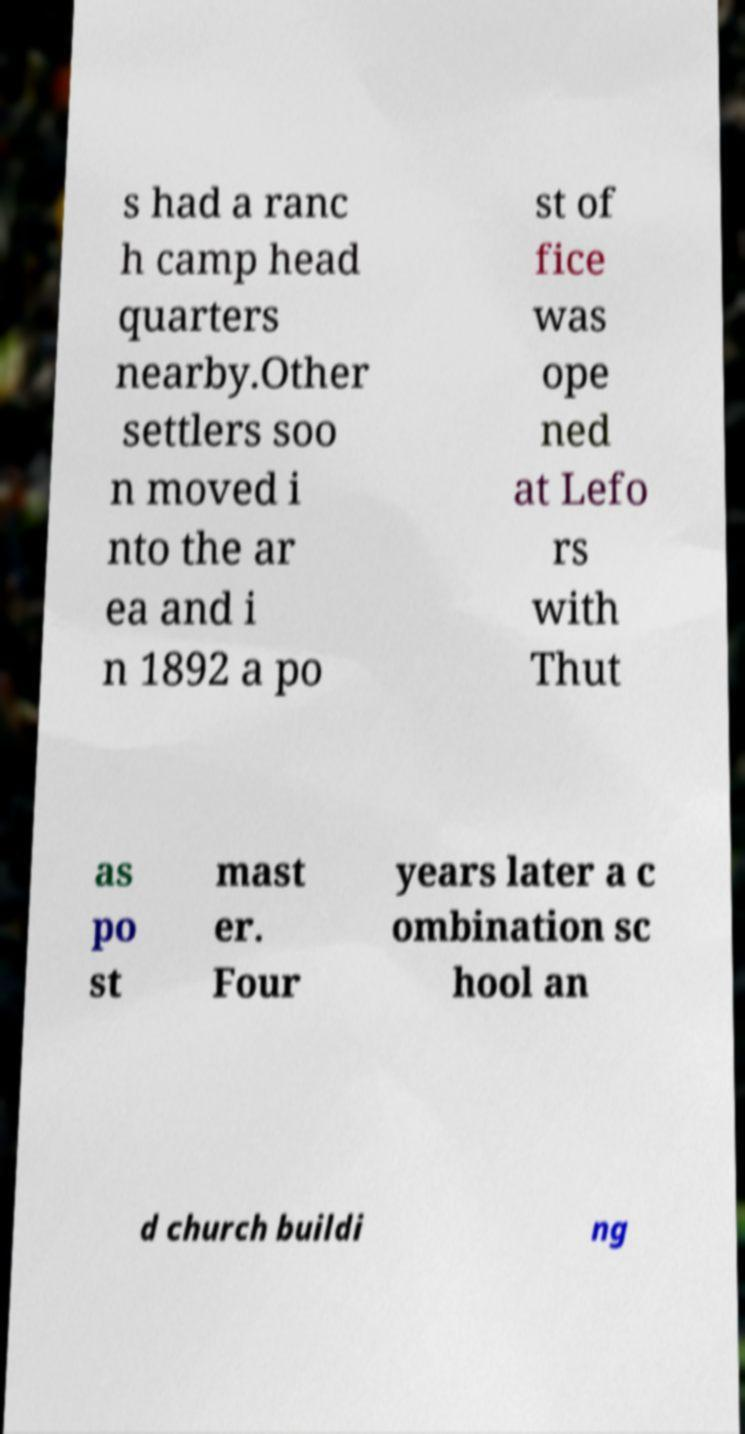Can you read and provide the text displayed in the image?This photo seems to have some interesting text. Can you extract and type it out for me? s had a ranc h camp head quarters nearby.Other settlers soo n moved i nto the ar ea and i n 1892 a po st of fice was ope ned at Lefo rs with Thut as po st mast er. Four years later a c ombination sc hool an d church buildi ng 